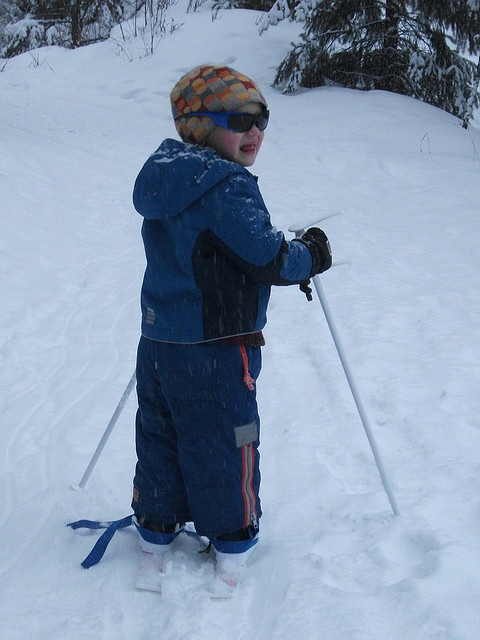Describe the objects in this image and their specific colors. I can see people in gray, black, navy, and darkblue tones and skis in gray, darkgray, and lightblue tones in this image. 